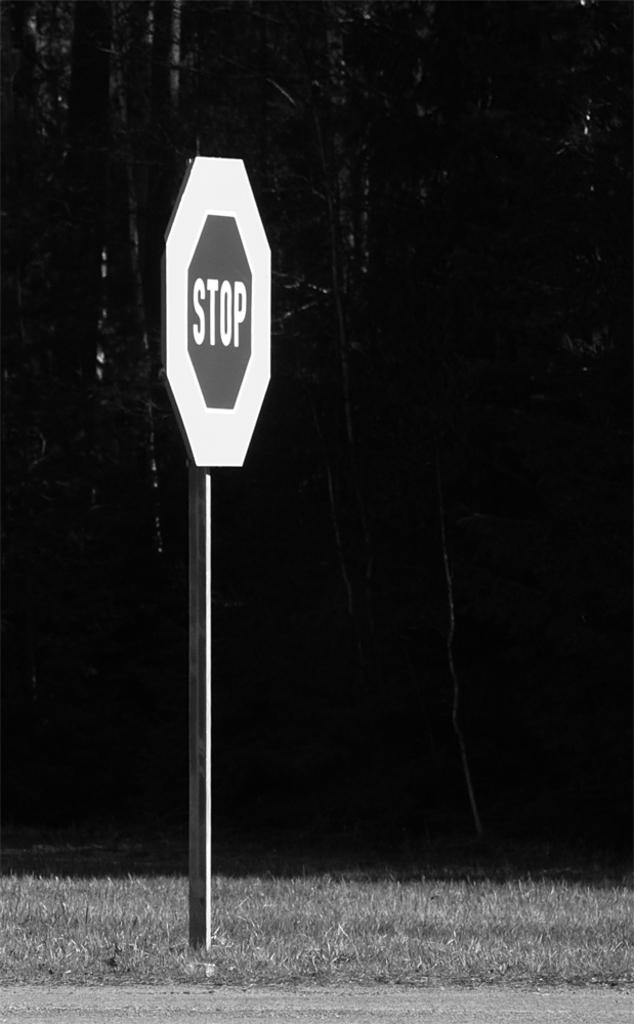What is the standard procedure when approaching a crossroads junction in a car?
Offer a terse response. Stop. 